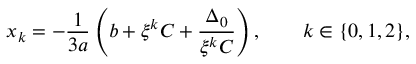Convert formula to latex. <formula><loc_0><loc_0><loc_500><loc_500>x _ { k } = - { \frac { 1 } { 3 a } } \left ( b + \xi ^ { k } C + { \frac { \Delta _ { 0 } } { \xi ^ { k } C } } \right ) , \quad k \in \{ 0 , 1 , 2 \} { , }</formula> 